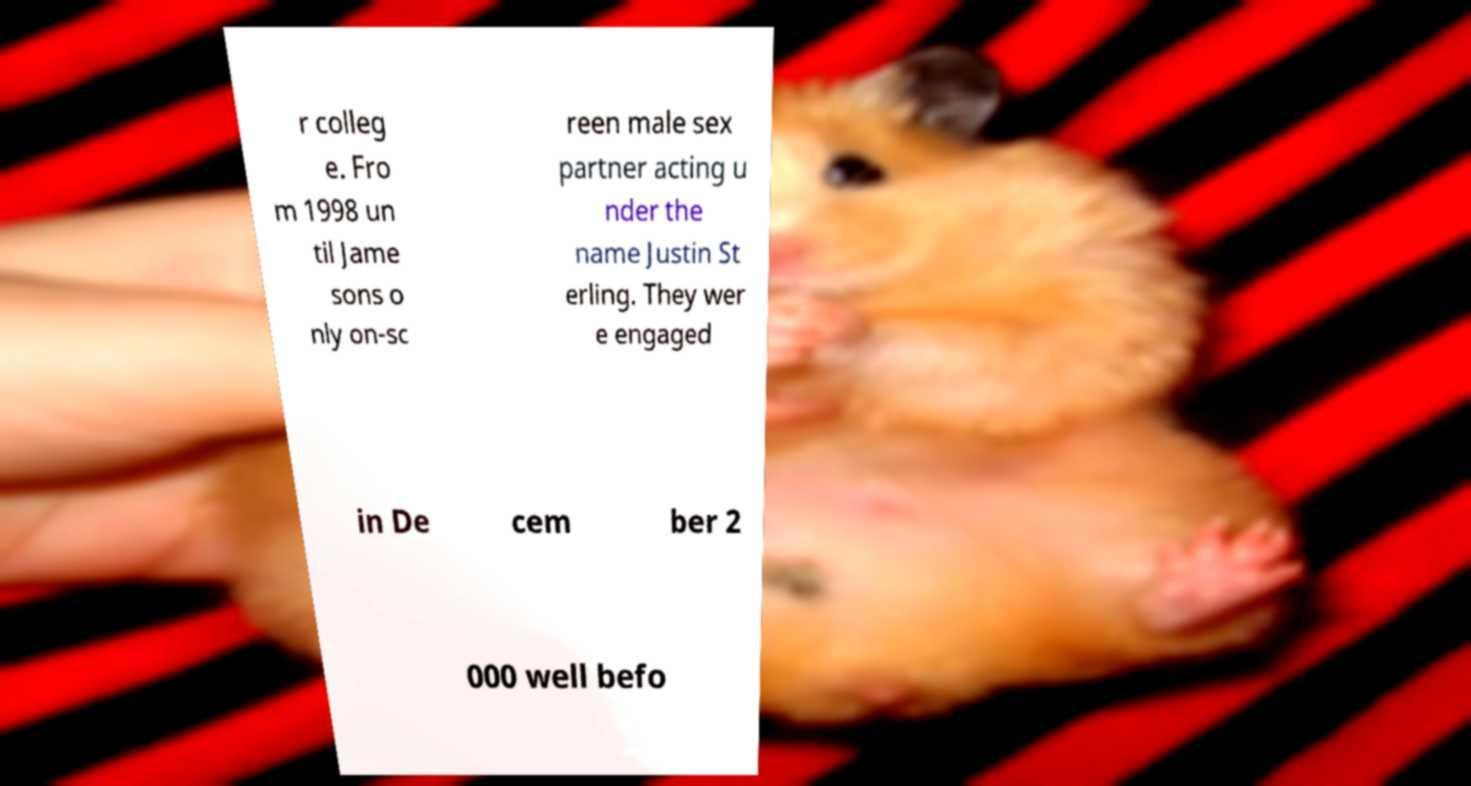Could you extract and type out the text from this image? r colleg e. Fro m 1998 un til Jame sons o nly on-sc reen male sex partner acting u nder the name Justin St erling. They wer e engaged in De cem ber 2 000 well befo 